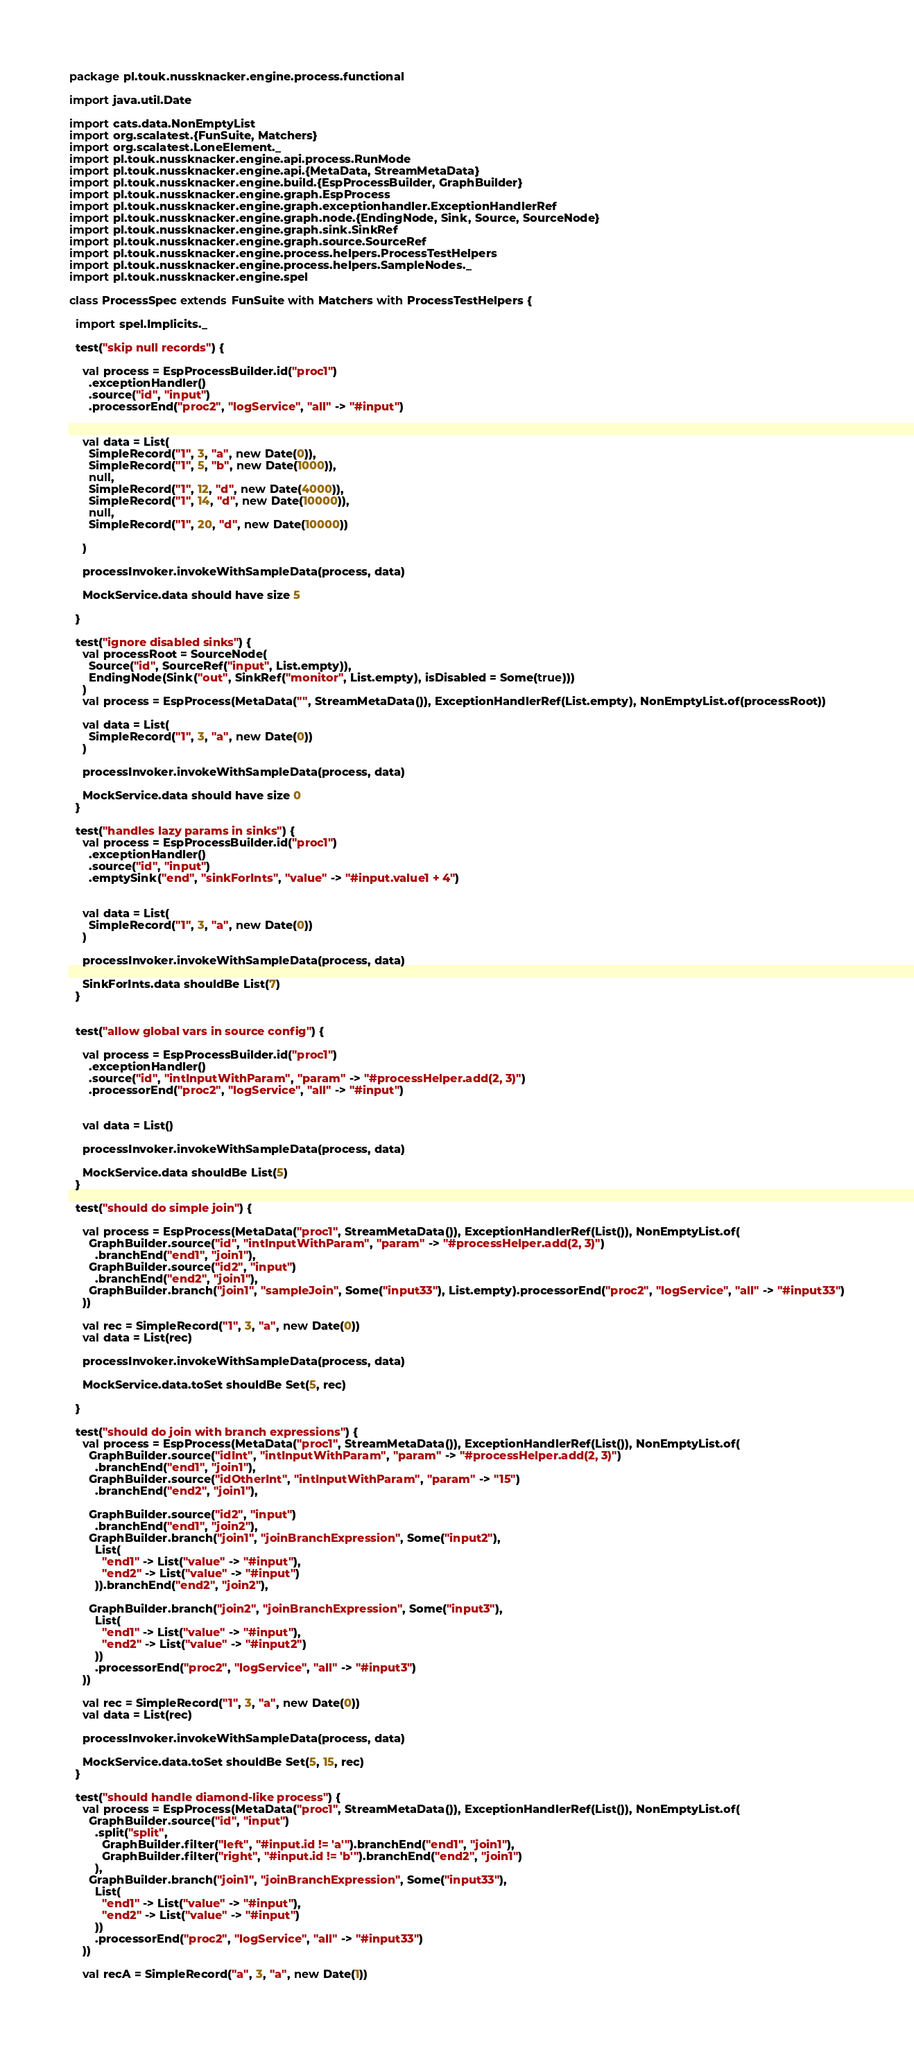Convert code to text. <code><loc_0><loc_0><loc_500><loc_500><_Scala_>package pl.touk.nussknacker.engine.process.functional

import java.util.Date

import cats.data.NonEmptyList
import org.scalatest.{FunSuite, Matchers}
import org.scalatest.LoneElement._
import pl.touk.nussknacker.engine.api.process.RunMode
import pl.touk.nussknacker.engine.api.{MetaData, StreamMetaData}
import pl.touk.nussknacker.engine.build.{EspProcessBuilder, GraphBuilder}
import pl.touk.nussknacker.engine.graph.EspProcess
import pl.touk.nussknacker.engine.graph.exceptionhandler.ExceptionHandlerRef
import pl.touk.nussknacker.engine.graph.node.{EndingNode, Sink, Source, SourceNode}
import pl.touk.nussknacker.engine.graph.sink.SinkRef
import pl.touk.nussknacker.engine.graph.source.SourceRef
import pl.touk.nussknacker.engine.process.helpers.ProcessTestHelpers
import pl.touk.nussknacker.engine.process.helpers.SampleNodes._
import pl.touk.nussknacker.engine.spel

class ProcessSpec extends FunSuite with Matchers with ProcessTestHelpers {

  import spel.Implicits._

  test("skip null records") {

    val process = EspProcessBuilder.id("proc1")
      .exceptionHandler()
      .source("id", "input")
      .processorEnd("proc2", "logService", "all" -> "#input")


    val data = List(
      SimpleRecord("1", 3, "a", new Date(0)),
      SimpleRecord("1", 5, "b", new Date(1000)),
      null,
      SimpleRecord("1", 12, "d", new Date(4000)),
      SimpleRecord("1", 14, "d", new Date(10000)),
      null,
      SimpleRecord("1", 20, "d", new Date(10000))

    )

    processInvoker.invokeWithSampleData(process, data)

    MockService.data should have size 5

  }

  test("ignore disabled sinks") {
    val processRoot = SourceNode(
      Source("id", SourceRef("input", List.empty)),
      EndingNode(Sink("out", SinkRef("monitor", List.empty), isDisabled = Some(true)))
    )
    val process = EspProcess(MetaData("", StreamMetaData()), ExceptionHandlerRef(List.empty), NonEmptyList.of(processRoot))

    val data = List(
      SimpleRecord("1", 3, "a", new Date(0))
    )

    processInvoker.invokeWithSampleData(process, data)

    MockService.data should have size 0
  }

  test("handles lazy params in sinks") {
    val process = EspProcessBuilder.id("proc1")
      .exceptionHandler()
      .source("id", "input")
      .emptySink("end", "sinkForInts", "value" -> "#input.value1 + 4")


    val data = List(
      SimpleRecord("1", 3, "a", new Date(0))
    )

    processInvoker.invokeWithSampleData(process, data)

    SinkForInts.data shouldBe List(7)
  }


  test("allow global vars in source config") {

    val process = EspProcessBuilder.id("proc1")
      .exceptionHandler()
      .source("id", "intInputWithParam", "param" -> "#processHelper.add(2, 3)")
      .processorEnd("proc2", "logService", "all" -> "#input")


    val data = List()

    processInvoker.invokeWithSampleData(process, data)

    MockService.data shouldBe List(5)
  }

  test("should do simple join") {

    val process = EspProcess(MetaData("proc1", StreamMetaData()), ExceptionHandlerRef(List()), NonEmptyList.of(
      GraphBuilder.source("id", "intInputWithParam", "param" -> "#processHelper.add(2, 3)")
        .branchEnd("end1", "join1"),
      GraphBuilder.source("id2", "input")
        .branchEnd("end2", "join1"),
      GraphBuilder.branch("join1", "sampleJoin", Some("input33"), List.empty).processorEnd("proc2", "logService", "all" -> "#input33")
    ))

    val rec = SimpleRecord("1", 3, "a", new Date(0))
    val data = List(rec)

    processInvoker.invokeWithSampleData(process, data)

    MockService.data.toSet shouldBe Set(5, rec)

  }

  test("should do join with branch expressions") {
    val process = EspProcess(MetaData("proc1", StreamMetaData()), ExceptionHandlerRef(List()), NonEmptyList.of(
      GraphBuilder.source("idInt", "intInputWithParam", "param" -> "#processHelper.add(2, 3)")
        .branchEnd("end1", "join1"),
      GraphBuilder.source("idOtherInt", "intInputWithParam", "param" -> "15")
        .branchEnd("end2", "join1"),

      GraphBuilder.source("id2", "input")
        .branchEnd("end1", "join2"),
      GraphBuilder.branch("join1", "joinBranchExpression", Some("input2"),
        List(
          "end1" -> List("value" -> "#input"),
          "end2" -> List("value" -> "#input")
        )).branchEnd("end2", "join2"),

      GraphBuilder.branch("join2", "joinBranchExpression", Some("input3"),
        List(
          "end1" -> List("value" -> "#input"),
          "end2" -> List("value" -> "#input2")
        ))
        .processorEnd("proc2", "logService", "all" -> "#input3")
    ))

    val rec = SimpleRecord("1", 3, "a", new Date(0))
    val data = List(rec)

    processInvoker.invokeWithSampleData(process, data)

    MockService.data.toSet shouldBe Set(5, 15, rec)
  }

  test("should handle diamond-like process") {
    val process = EspProcess(MetaData("proc1", StreamMetaData()), ExceptionHandlerRef(List()), NonEmptyList.of(
      GraphBuilder.source("id", "input")
        .split("split",
          GraphBuilder.filter("left", "#input.id != 'a'").branchEnd("end1", "join1"),
          GraphBuilder.filter("right", "#input.id != 'b'").branchEnd("end2", "join1")
        ),
      GraphBuilder.branch("join1", "joinBranchExpression", Some("input33"),
        List(
          "end1" -> List("value" -> "#input"),
          "end2" -> List("value" -> "#input")
        ))
        .processorEnd("proc2", "logService", "all" -> "#input33")
    ))

    val recA = SimpleRecord("a", 3, "a", new Date(1))</code> 